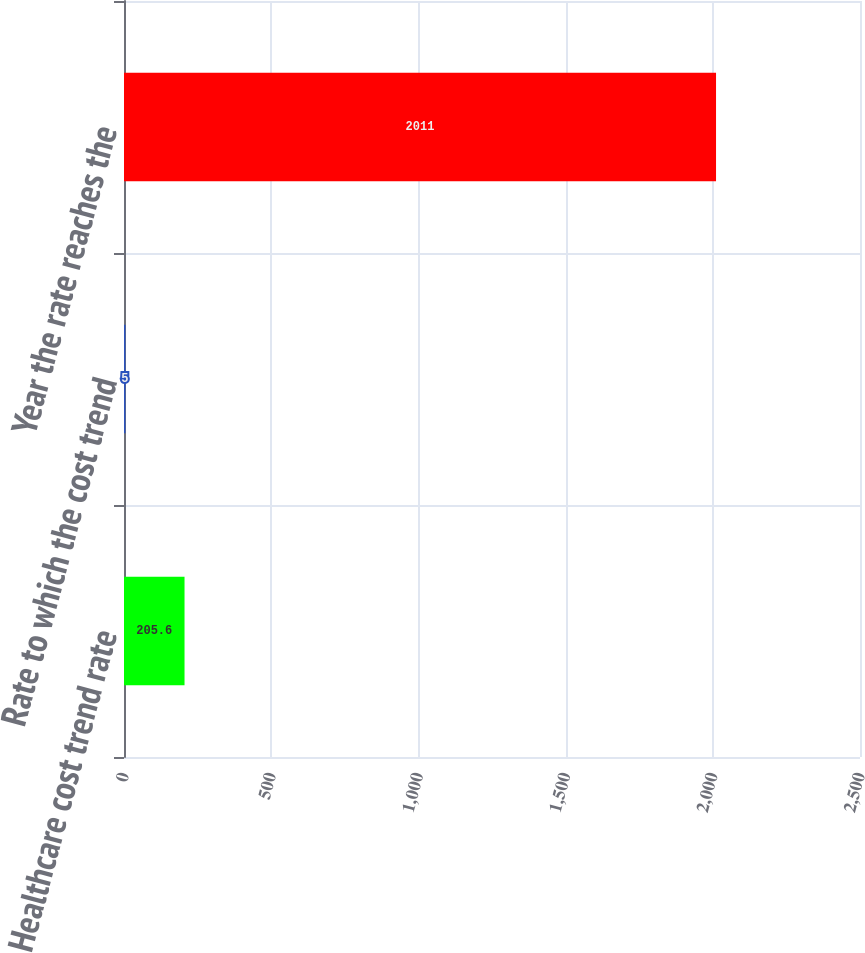<chart> <loc_0><loc_0><loc_500><loc_500><bar_chart><fcel>Healthcare cost trend rate<fcel>Rate to which the cost trend<fcel>Year the rate reaches the<nl><fcel>205.6<fcel>5<fcel>2011<nl></chart> 